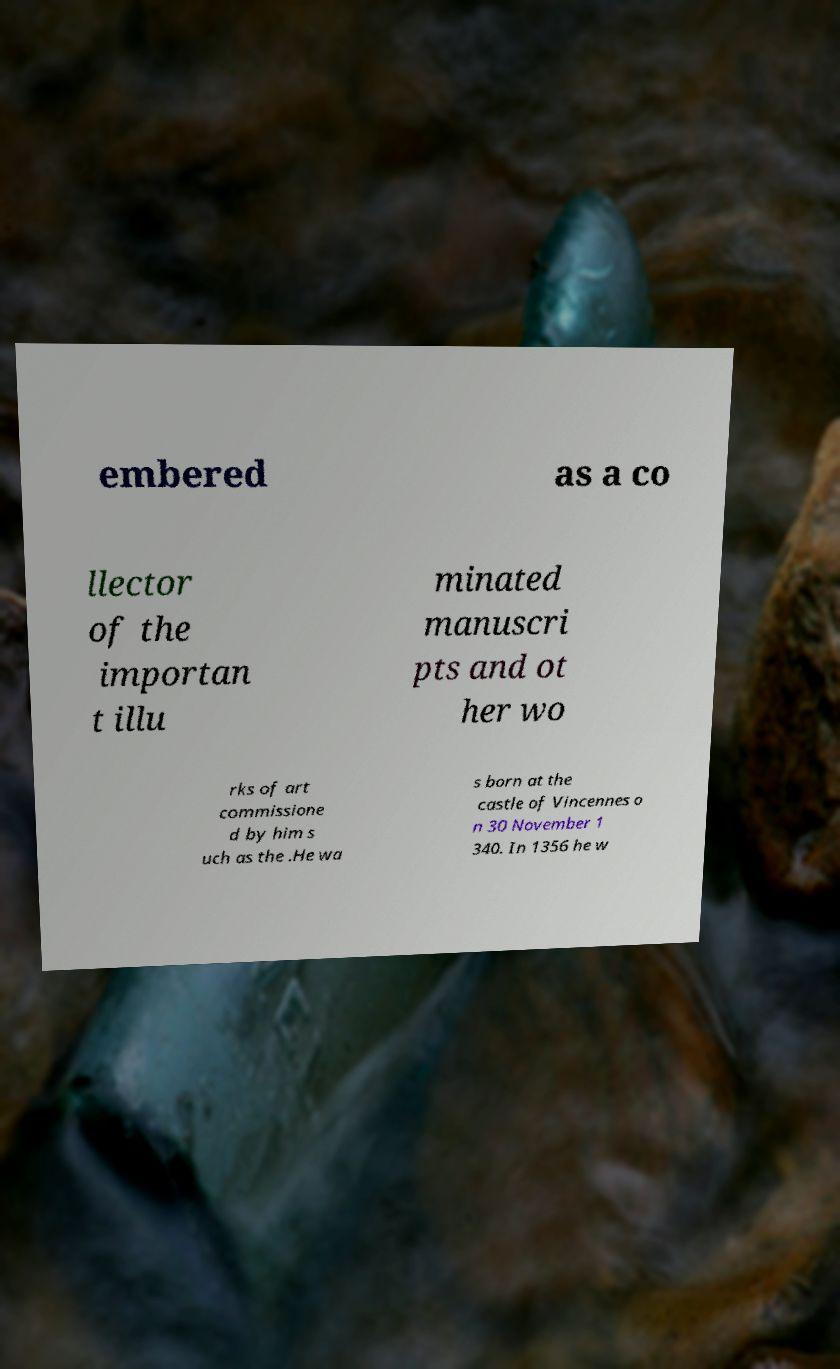I need the written content from this picture converted into text. Can you do that? embered as a co llector of the importan t illu minated manuscri pts and ot her wo rks of art commissione d by him s uch as the .He wa s born at the castle of Vincennes o n 30 November 1 340. In 1356 he w 